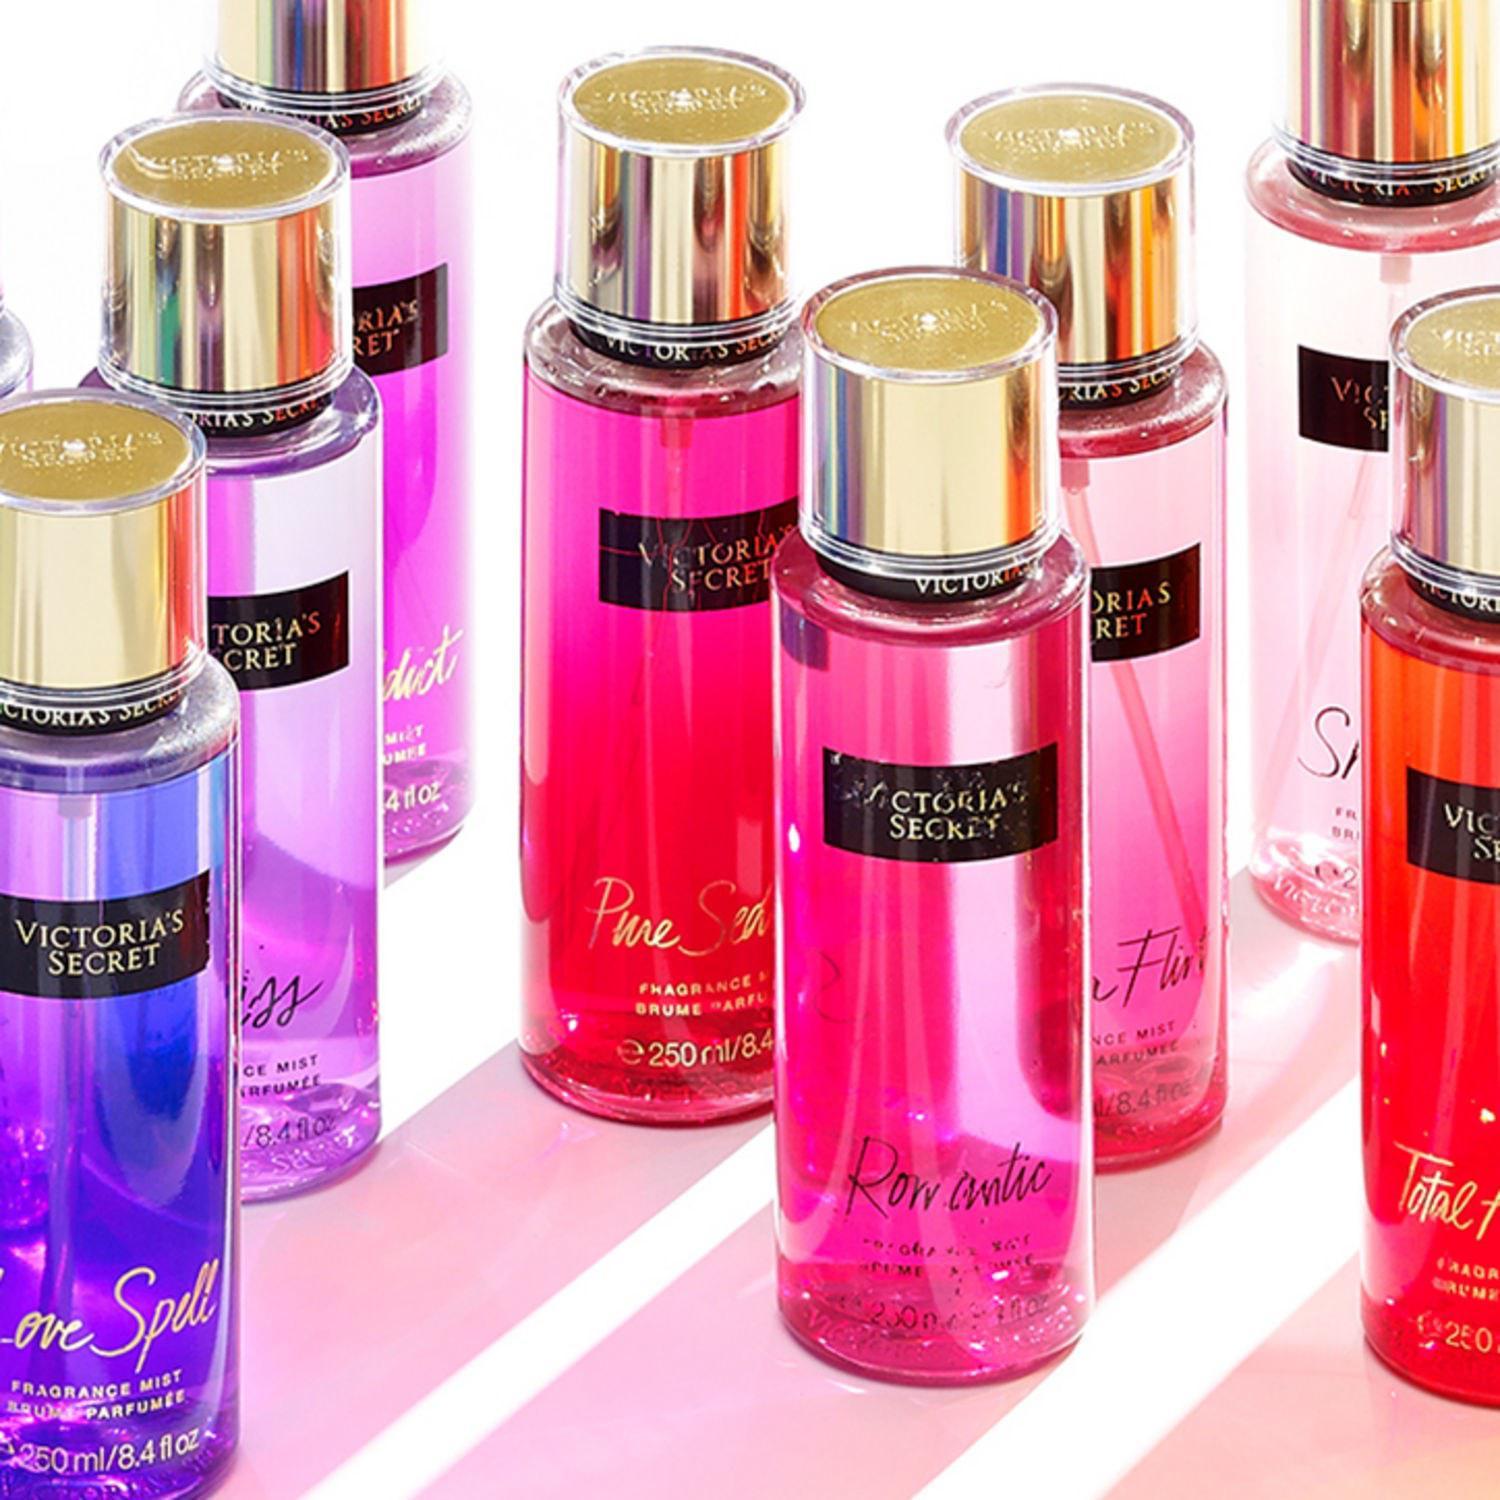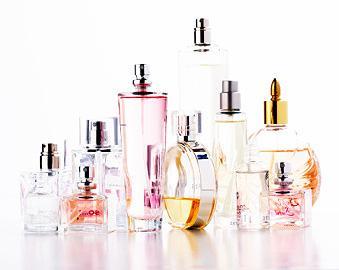The first image is the image on the left, the second image is the image on the right. Examine the images to the left and right. Is the description "One image contains eight fragrance bottles in various shapes and colors, including one purplish bottle topped with a rose shape." accurate? Answer yes or no. No. 